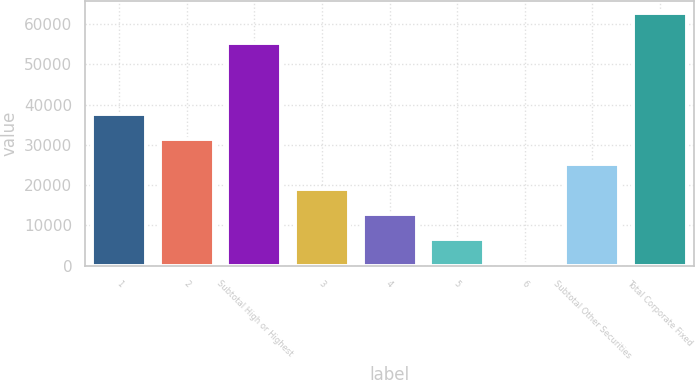<chart> <loc_0><loc_0><loc_500><loc_500><bar_chart><fcel>1<fcel>2<fcel>Subtotal High or Highest<fcel>3<fcel>4<fcel>5<fcel>6<fcel>Subtotal Other Securities<fcel>Total Corporate Fixed<nl><fcel>37728.8<fcel>31493.5<fcel>55366<fcel>19022.9<fcel>12787.6<fcel>6552.3<fcel>317<fcel>25258.2<fcel>62670<nl></chart> 